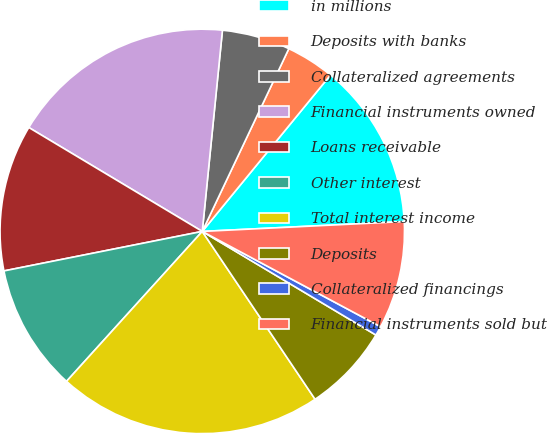Convert chart. <chart><loc_0><loc_0><loc_500><loc_500><pie_chart><fcel>in millions<fcel>Deposits with banks<fcel>Collateralized agreements<fcel>Financial instruments owned<fcel>Loans receivable<fcel>Other interest<fcel>Total interest income<fcel>Deposits<fcel>Collateralized financings<fcel>Financial instruments sold but<nl><fcel>13.29%<fcel>3.89%<fcel>5.45%<fcel>18.0%<fcel>11.72%<fcel>10.16%<fcel>21.13%<fcel>7.02%<fcel>0.75%<fcel>8.59%<nl></chart> 